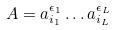<formula> <loc_0><loc_0><loc_500><loc_500>A = a _ { i _ { 1 } } ^ { \epsilon _ { 1 } } \dots a _ { i _ { L } } ^ { \epsilon _ { L } }</formula> 